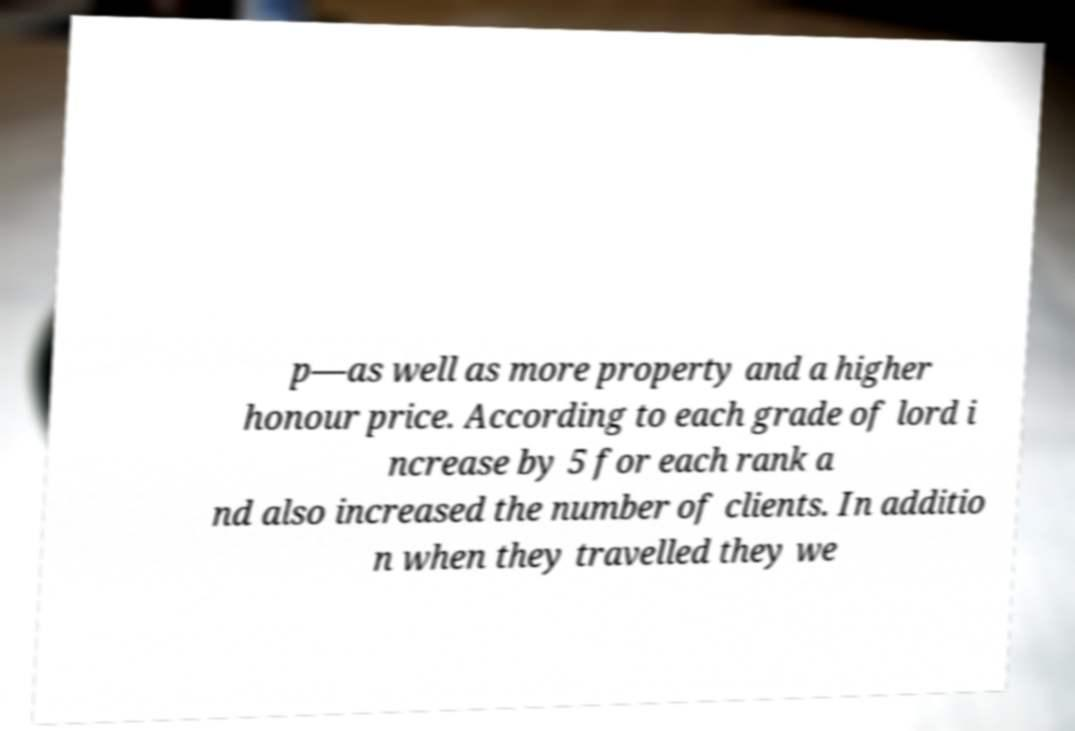Can you read and provide the text displayed in the image?This photo seems to have some interesting text. Can you extract and type it out for me? p—as well as more property and a higher honour price. According to each grade of lord i ncrease by 5 for each rank a nd also increased the number of clients. In additio n when they travelled they we 